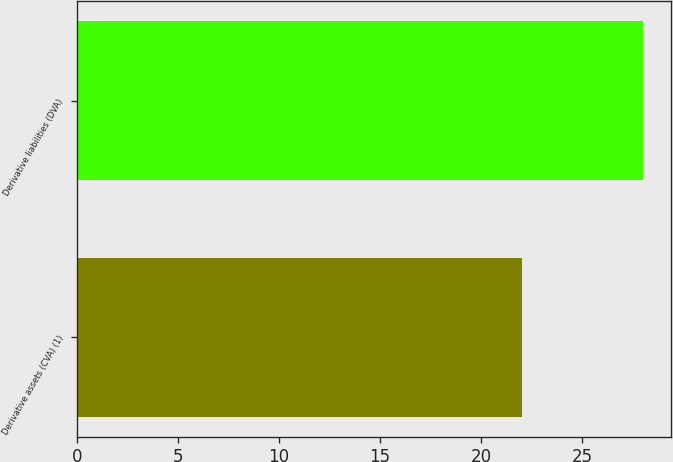Convert chart. <chart><loc_0><loc_0><loc_500><loc_500><bar_chart><fcel>Derivative assets (CVA) (1)<fcel>Derivative liabilities (DVA)<nl><fcel>22<fcel>28<nl></chart> 